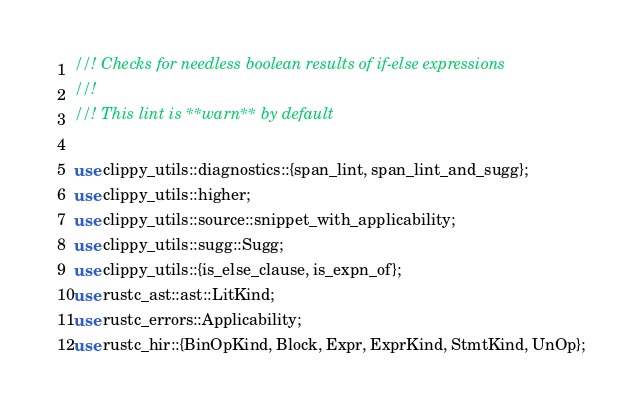Convert code to text. <code><loc_0><loc_0><loc_500><loc_500><_Rust_>//! Checks for needless boolean results of if-else expressions
//!
//! This lint is **warn** by default

use clippy_utils::diagnostics::{span_lint, span_lint_and_sugg};
use clippy_utils::higher;
use clippy_utils::source::snippet_with_applicability;
use clippy_utils::sugg::Sugg;
use clippy_utils::{is_else_clause, is_expn_of};
use rustc_ast::ast::LitKind;
use rustc_errors::Applicability;
use rustc_hir::{BinOpKind, Block, Expr, ExprKind, StmtKind, UnOp};</code> 